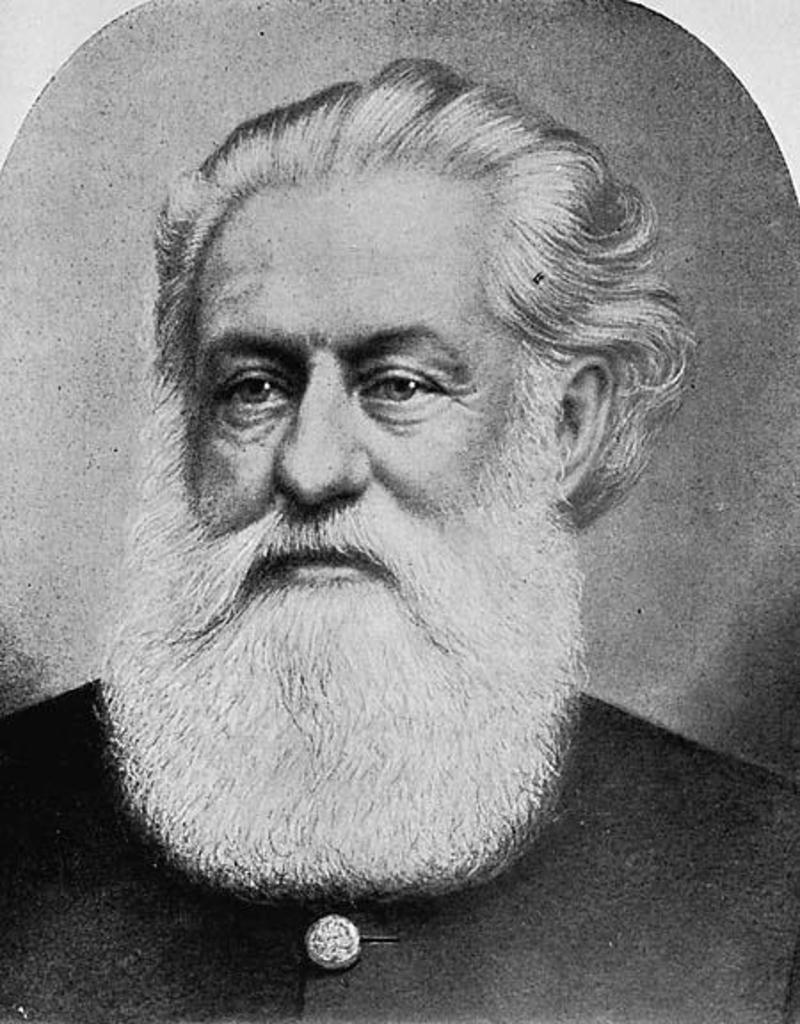What is the color scheme of the image? The image is black and white. Can you describe the main subject of the image? There is a person with a beard in the center of the image. What word is the toad saying in the image? There is no toad present in the image, and therefore no words can be attributed to it. 